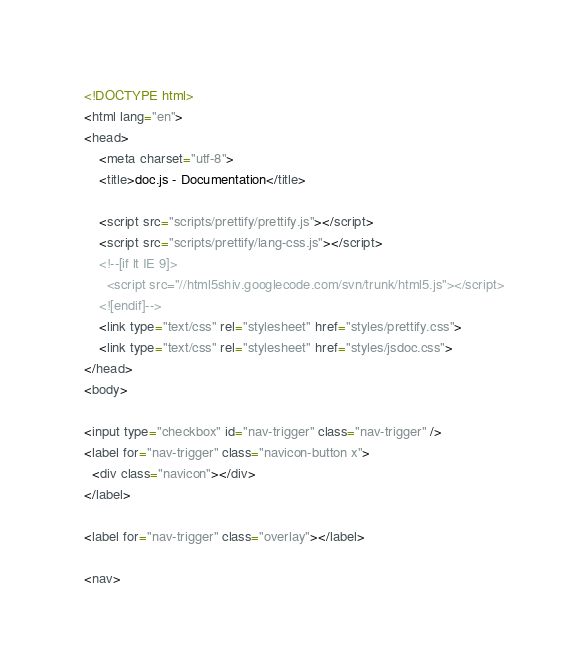Convert code to text. <code><loc_0><loc_0><loc_500><loc_500><_HTML_><!DOCTYPE html>
<html lang="en">
<head>
    <meta charset="utf-8">
    <title>doc.js - Documentation</title>

    <script src="scripts/prettify/prettify.js"></script>
    <script src="scripts/prettify/lang-css.js"></script>
    <!--[if lt IE 9]>
      <script src="//html5shiv.googlecode.com/svn/trunk/html5.js"></script>
    <![endif]-->
    <link type="text/css" rel="stylesheet" href="styles/prettify.css">
    <link type="text/css" rel="stylesheet" href="styles/jsdoc.css">
</head>
<body>

<input type="checkbox" id="nav-trigger" class="nav-trigger" />
<label for="nav-trigger" class="navicon-button x">
  <div class="navicon"></div>
</label>

<label for="nav-trigger" class="overlay"></label>

<nav></code> 